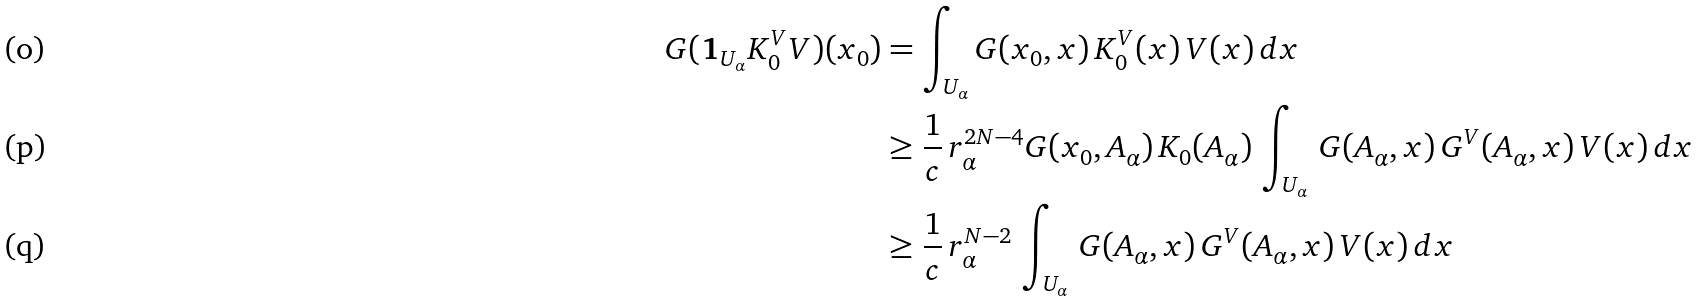<formula> <loc_0><loc_0><loc_500><loc_500>G ( { \mathbf 1 } _ { U _ { \alpha } } K _ { 0 } ^ { V } V ) ( x _ { 0 } ) & = \int _ { U _ { \alpha } } G ( x _ { 0 } , x ) \, K _ { 0 } ^ { V } ( x ) \, V ( x ) \, d x \\ & \geq { \frac { 1 } { c } } \, r _ { \alpha } ^ { 2 N - 4 } G ( x _ { 0 } , A _ { \alpha } ) \, K _ { 0 } ( A _ { \alpha } ) \, \int _ { U _ { \alpha } } \, G ( A _ { \alpha } , x ) \, G ^ { V } ( A _ { \alpha } , x ) \, V ( x ) \, d x \\ & \geq { \frac { 1 } { c } } \, r _ { \alpha } ^ { N - 2 } \, \int _ { U _ { \alpha } } \, G ( A _ { \alpha } , x ) \, G ^ { V } ( A _ { \alpha } , x ) \, V ( x ) \, d x</formula> 